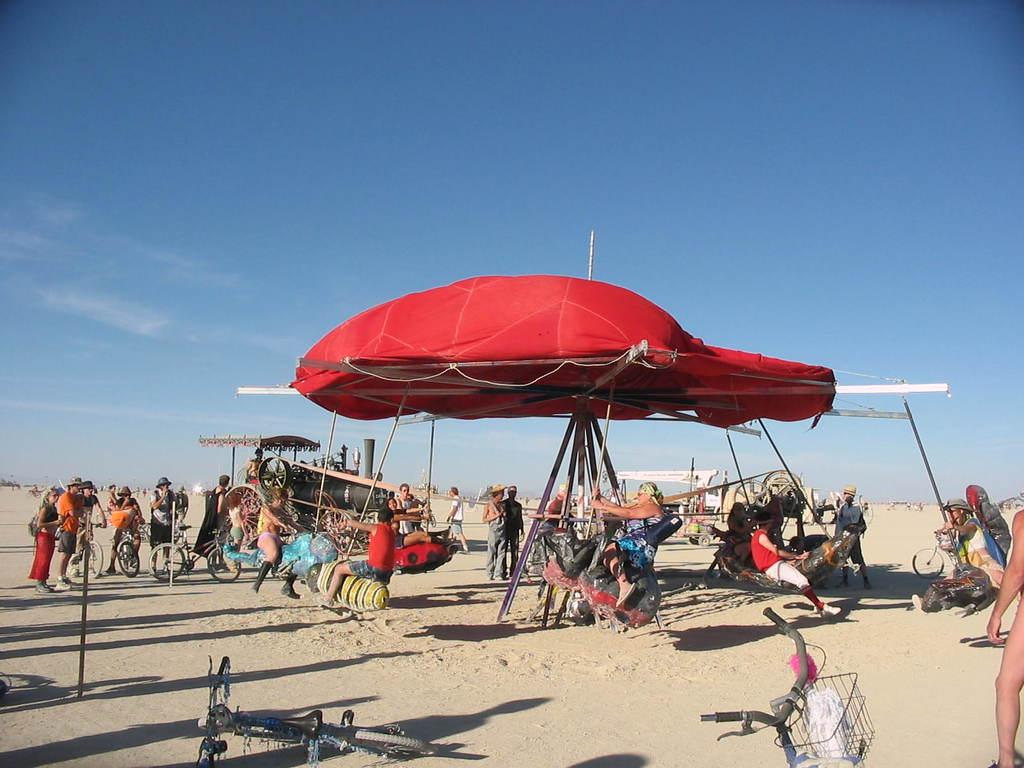How many people are in the image? There is a group of people in the image, but the exact number cannot be determined from the provided facts. What type of surface are the people standing on? The people are on sand in the image. What can be seen in the background of the image? The sky is visible in the background of the image. What type of plantation can be seen in the image? There is no plantation present in the image; it features a group of people on sand with the sky visible in the background. How does the air affect the people in the image? The provided facts do not mention any specific effects of the air on the people in the image. 